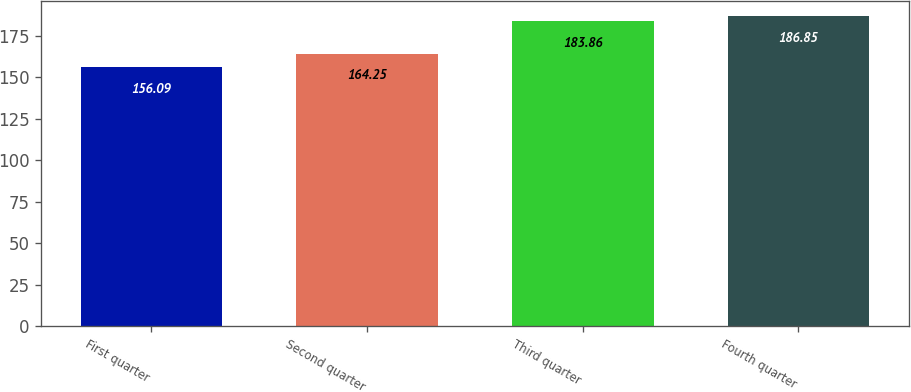Convert chart. <chart><loc_0><loc_0><loc_500><loc_500><bar_chart><fcel>First quarter<fcel>Second quarter<fcel>Third quarter<fcel>Fourth quarter<nl><fcel>156.09<fcel>164.25<fcel>183.86<fcel>186.85<nl></chart> 